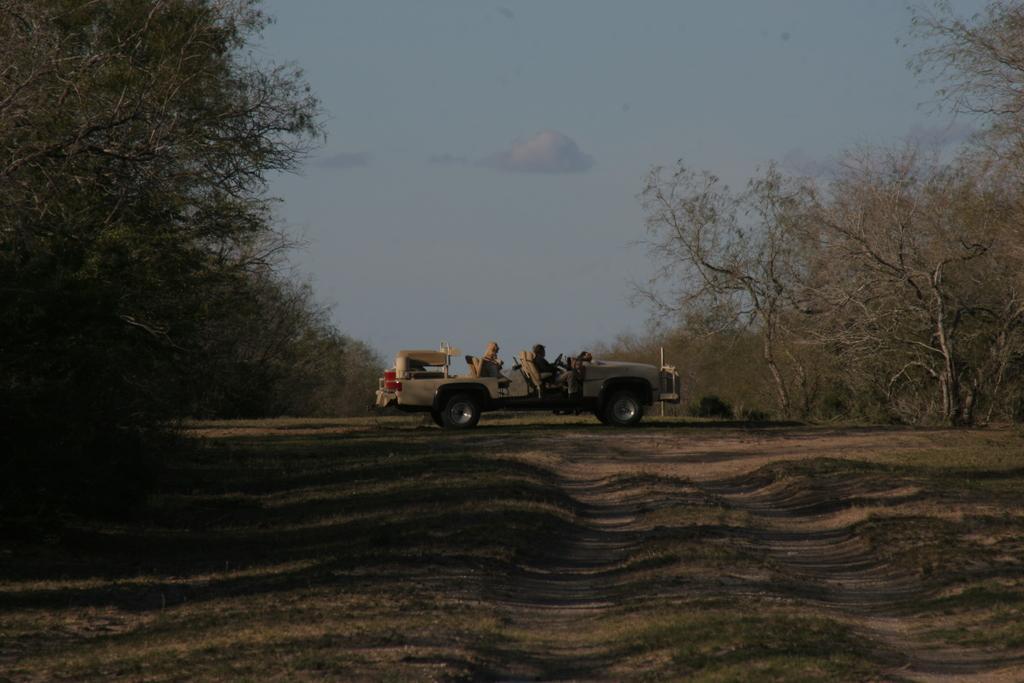Could you give a brief overview of what you see in this image? In this picture we can see the van in the forest. Behind there are some dry trees. In the front bottom side there is a ground. 